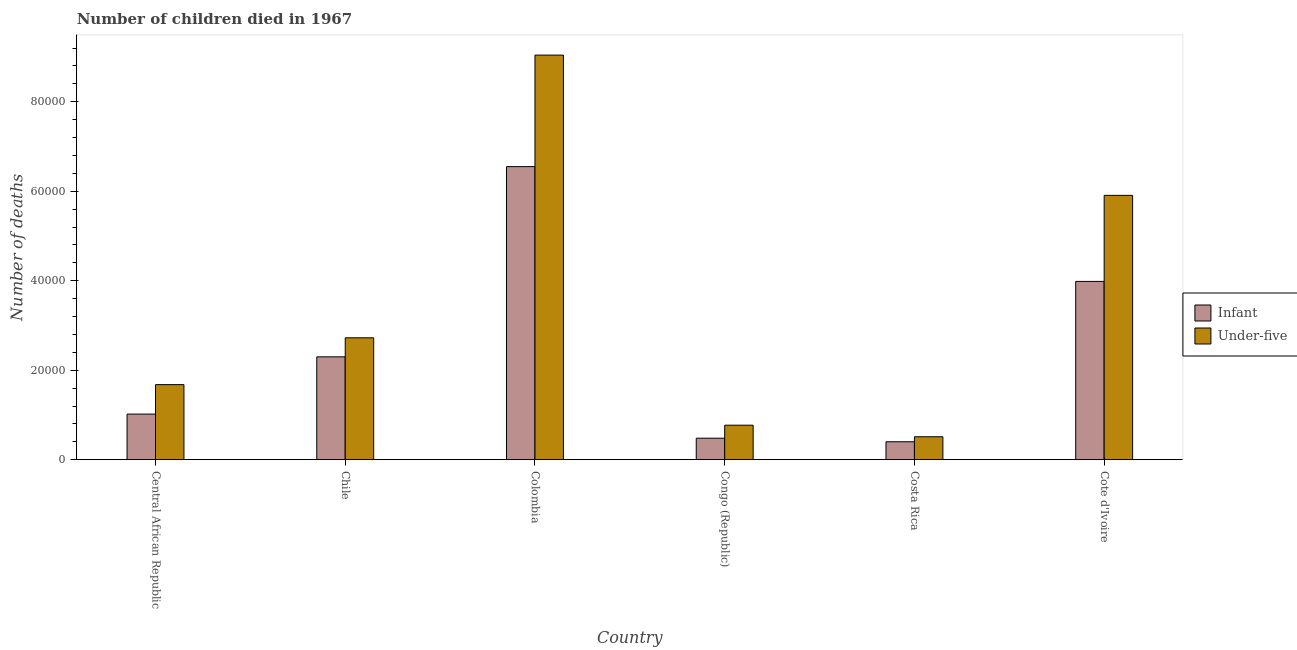How many different coloured bars are there?
Ensure brevity in your answer.  2. Are the number of bars per tick equal to the number of legend labels?
Offer a terse response. Yes. Are the number of bars on each tick of the X-axis equal?
Offer a very short reply. Yes. How many bars are there on the 2nd tick from the left?
Keep it short and to the point. 2. How many bars are there on the 4th tick from the right?
Keep it short and to the point. 2. What is the label of the 6th group of bars from the left?
Ensure brevity in your answer.  Cote d'Ivoire. In how many cases, is the number of bars for a given country not equal to the number of legend labels?
Your answer should be very brief. 0. What is the number of under-five deaths in Congo (Republic)?
Make the answer very short. 7710. Across all countries, what is the maximum number of under-five deaths?
Make the answer very short. 9.04e+04. Across all countries, what is the minimum number of infant deaths?
Make the answer very short. 4011. In which country was the number of under-five deaths maximum?
Keep it short and to the point. Colombia. What is the total number of infant deaths in the graph?
Your answer should be very brief. 1.47e+05. What is the difference between the number of infant deaths in Chile and that in Cote d'Ivoire?
Your answer should be compact. -1.69e+04. What is the difference between the number of under-five deaths in Chile and the number of infant deaths in Cote d'Ivoire?
Provide a short and direct response. -1.26e+04. What is the average number of under-five deaths per country?
Offer a very short reply. 3.44e+04. What is the difference between the number of under-five deaths and number of infant deaths in Chile?
Ensure brevity in your answer.  4252. In how many countries, is the number of under-five deaths greater than 28000 ?
Ensure brevity in your answer.  2. What is the ratio of the number of under-five deaths in Costa Rica to that in Cote d'Ivoire?
Provide a short and direct response. 0.09. What is the difference between the highest and the second highest number of infant deaths?
Your answer should be very brief. 2.57e+04. What is the difference between the highest and the lowest number of infant deaths?
Make the answer very short. 6.15e+04. In how many countries, is the number of under-five deaths greater than the average number of under-five deaths taken over all countries?
Your answer should be very brief. 2. What does the 1st bar from the left in Congo (Republic) represents?
Provide a succinct answer. Infant. What does the 2nd bar from the right in Colombia represents?
Make the answer very short. Infant. How many countries are there in the graph?
Provide a short and direct response. 6. Does the graph contain any zero values?
Make the answer very short. No. How many legend labels are there?
Your response must be concise. 2. What is the title of the graph?
Offer a terse response. Number of children died in 1967. Does "Primary completion rate" appear as one of the legend labels in the graph?
Your response must be concise. No. What is the label or title of the X-axis?
Keep it short and to the point. Country. What is the label or title of the Y-axis?
Offer a terse response. Number of deaths. What is the Number of deaths of Infant in Central African Republic?
Offer a terse response. 1.02e+04. What is the Number of deaths in Under-five in Central African Republic?
Offer a terse response. 1.68e+04. What is the Number of deaths in Infant in Chile?
Give a very brief answer. 2.30e+04. What is the Number of deaths of Under-five in Chile?
Ensure brevity in your answer.  2.72e+04. What is the Number of deaths of Infant in Colombia?
Your answer should be compact. 6.55e+04. What is the Number of deaths in Under-five in Colombia?
Make the answer very short. 9.04e+04. What is the Number of deaths in Infant in Congo (Republic)?
Make the answer very short. 4806. What is the Number of deaths of Under-five in Congo (Republic)?
Offer a very short reply. 7710. What is the Number of deaths of Infant in Costa Rica?
Your answer should be very brief. 4011. What is the Number of deaths of Under-five in Costa Rica?
Provide a succinct answer. 5127. What is the Number of deaths of Infant in Cote d'Ivoire?
Your answer should be very brief. 3.98e+04. What is the Number of deaths of Under-five in Cote d'Ivoire?
Offer a very short reply. 5.91e+04. Across all countries, what is the maximum Number of deaths of Infant?
Provide a short and direct response. 6.55e+04. Across all countries, what is the maximum Number of deaths of Under-five?
Provide a succinct answer. 9.04e+04. Across all countries, what is the minimum Number of deaths in Infant?
Give a very brief answer. 4011. Across all countries, what is the minimum Number of deaths of Under-five?
Your response must be concise. 5127. What is the total Number of deaths of Infant in the graph?
Provide a short and direct response. 1.47e+05. What is the total Number of deaths in Under-five in the graph?
Ensure brevity in your answer.  2.06e+05. What is the difference between the Number of deaths in Infant in Central African Republic and that in Chile?
Provide a succinct answer. -1.28e+04. What is the difference between the Number of deaths in Under-five in Central African Republic and that in Chile?
Make the answer very short. -1.05e+04. What is the difference between the Number of deaths of Infant in Central African Republic and that in Colombia?
Your answer should be very brief. -5.53e+04. What is the difference between the Number of deaths in Under-five in Central African Republic and that in Colombia?
Keep it short and to the point. -7.36e+04. What is the difference between the Number of deaths in Infant in Central African Republic and that in Congo (Republic)?
Give a very brief answer. 5389. What is the difference between the Number of deaths of Under-five in Central African Republic and that in Congo (Republic)?
Make the answer very short. 9065. What is the difference between the Number of deaths of Infant in Central African Republic and that in Costa Rica?
Offer a terse response. 6184. What is the difference between the Number of deaths of Under-five in Central African Republic and that in Costa Rica?
Keep it short and to the point. 1.16e+04. What is the difference between the Number of deaths in Infant in Central African Republic and that in Cote d'Ivoire?
Offer a very short reply. -2.96e+04. What is the difference between the Number of deaths in Under-five in Central African Republic and that in Cote d'Ivoire?
Your response must be concise. -4.23e+04. What is the difference between the Number of deaths of Infant in Chile and that in Colombia?
Make the answer very short. -4.25e+04. What is the difference between the Number of deaths in Under-five in Chile and that in Colombia?
Your answer should be compact. -6.32e+04. What is the difference between the Number of deaths in Infant in Chile and that in Congo (Republic)?
Your answer should be compact. 1.82e+04. What is the difference between the Number of deaths of Under-five in Chile and that in Congo (Republic)?
Your answer should be very brief. 1.95e+04. What is the difference between the Number of deaths of Infant in Chile and that in Costa Rica?
Your answer should be very brief. 1.90e+04. What is the difference between the Number of deaths in Under-five in Chile and that in Costa Rica?
Offer a terse response. 2.21e+04. What is the difference between the Number of deaths in Infant in Chile and that in Cote d'Ivoire?
Provide a short and direct response. -1.69e+04. What is the difference between the Number of deaths in Under-five in Chile and that in Cote d'Ivoire?
Your answer should be compact. -3.18e+04. What is the difference between the Number of deaths of Infant in Colombia and that in Congo (Republic)?
Your response must be concise. 6.07e+04. What is the difference between the Number of deaths in Under-five in Colombia and that in Congo (Republic)?
Offer a very short reply. 8.27e+04. What is the difference between the Number of deaths of Infant in Colombia and that in Costa Rica?
Provide a short and direct response. 6.15e+04. What is the difference between the Number of deaths of Under-five in Colombia and that in Costa Rica?
Provide a short and direct response. 8.53e+04. What is the difference between the Number of deaths in Infant in Colombia and that in Cote d'Ivoire?
Provide a succinct answer. 2.57e+04. What is the difference between the Number of deaths of Under-five in Colombia and that in Cote d'Ivoire?
Keep it short and to the point. 3.13e+04. What is the difference between the Number of deaths in Infant in Congo (Republic) and that in Costa Rica?
Give a very brief answer. 795. What is the difference between the Number of deaths in Under-five in Congo (Republic) and that in Costa Rica?
Offer a very short reply. 2583. What is the difference between the Number of deaths of Infant in Congo (Republic) and that in Cote d'Ivoire?
Your response must be concise. -3.50e+04. What is the difference between the Number of deaths in Under-five in Congo (Republic) and that in Cote d'Ivoire?
Provide a short and direct response. -5.14e+04. What is the difference between the Number of deaths of Infant in Costa Rica and that in Cote d'Ivoire?
Ensure brevity in your answer.  -3.58e+04. What is the difference between the Number of deaths of Under-five in Costa Rica and that in Cote d'Ivoire?
Give a very brief answer. -5.39e+04. What is the difference between the Number of deaths of Infant in Central African Republic and the Number of deaths of Under-five in Chile?
Give a very brief answer. -1.70e+04. What is the difference between the Number of deaths of Infant in Central African Republic and the Number of deaths of Under-five in Colombia?
Ensure brevity in your answer.  -8.02e+04. What is the difference between the Number of deaths in Infant in Central African Republic and the Number of deaths in Under-five in Congo (Republic)?
Your response must be concise. 2485. What is the difference between the Number of deaths of Infant in Central African Republic and the Number of deaths of Under-five in Costa Rica?
Provide a succinct answer. 5068. What is the difference between the Number of deaths of Infant in Central African Republic and the Number of deaths of Under-five in Cote d'Ivoire?
Provide a succinct answer. -4.89e+04. What is the difference between the Number of deaths in Infant in Chile and the Number of deaths in Under-five in Colombia?
Offer a terse response. -6.74e+04. What is the difference between the Number of deaths in Infant in Chile and the Number of deaths in Under-five in Congo (Republic)?
Offer a very short reply. 1.53e+04. What is the difference between the Number of deaths in Infant in Chile and the Number of deaths in Under-five in Costa Rica?
Make the answer very short. 1.79e+04. What is the difference between the Number of deaths in Infant in Chile and the Number of deaths in Under-five in Cote d'Ivoire?
Your response must be concise. -3.61e+04. What is the difference between the Number of deaths of Infant in Colombia and the Number of deaths of Under-five in Congo (Republic)?
Provide a succinct answer. 5.78e+04. What is the difference between the Number of deaths in Infant in Colombia and the Number of deaths in Under-five in Costa Rica?
Offer a terse response. 6.04e+04. What is the difference between the Number of deaths of Infant in Colombia and the Number of deaths of Under-five in Cote d'Ivoire?
Your answer should be compact. 6424. What is the difference between the Number of deaths of Infant in Congo (Republic) and the Number of deaths of Under-five in Costa Rica?
Ensure brevity in your answer.  -321. What is the difference between the Number of deaths in Infant in Congo (Republic) and the Number of deaths in Under-five in Cote d'Ivoire?
Offer a very short reply. -5.43e+04. What is the difference between the Number of deaths of Infant in Costa Rica and the Number of deaths of Under-five in Cote d'Ivoire?
Your answer should be compact. -5.51e+04. What is the average Number of deaths of Infant per country?
Give a very brief answer. 2.46e+04. What is the average Number of deaths of Under-five per country?
Offer a very short reply. 3.44e+04. What is the difference between the Number of deaths of Infant and Number of deaths of Under-five in Central African Republic?
Make the answer very short. -6580. What is the difference between the Number of deaths of Infant and Number of deaths of Under-five in Chile?
Keep it short and to the point. -4252. What is the difference between the Number of deaths of Infant and Number of deaths of Under-five in Colombia?
Give a very brief answer. -2.49e+04. What is the difference between the Number of deaths in Infant and Number of deaths in Under-five in Congo (Republic)?
Your response must be concise. -2904. What is the difference between the Number of deaths of Infant and Number of deaths of Under-five in Costa Rica?
Give a very brief answer. -1116. What is the difference between the Number of deaths of Infant and Number of deaths of Under-five in Cote d'Ivoire?
Your answer should be very brief. -1.92e+04. What is the ratio of the Number of deaths in Infant in Central African Republic to that in Chile?
Your answer should be compact. 0.44. What is the ratio of the Number of deaths in Under-five in Central African Republic to that in Chile?
Your answer should be compact. 0.62. What is the ratio of the Number of deaths of Infant in Central African Republic to that in Colombia?
Your response must be concise. 0.16. What is the ratio of the Number of deaths in Under-five in Central African Republic to that in Colombia?
Keep it short and to the point. 0.19. What is the ratio of the Number of deaths in Infant in Central African Republic to that in Congo (Republic)?
Provide a succinct answer. 2.12. What is the ratio of the Number of deaths of Under-five in Central African Republic to that in Congo (Republic)?
Ensure brevity in your answer.  2.18. What is the ratio of the Number of deaths of Infant in Central African Republic to that in Costa Rica?
Keep it short and to the point. 2.54. What is the ratio of the Number of deaths in Under-five in Central African Republic to that in Costa Rica?
Your answer should be very brief. 3.27. What is the ratio of the Number of deaths in Infant in Central African Republic to that in Cote d'Ivoire?
Offer a terse response. 0.26. What is the ratio of the Number of deaths in Under-five in Central African Republic to that in Cote d'Ivoire?
Make the answer very short. 0.28. What is the ratio of the Number of deaths of Infant in Chile to that in Colombia?
Your answer should be compact. 0.35. What is the ratio of the Number of deaths of Under-five in Chile to that in Colombia?
Ensure brevity in your answer.  0.3. What is the ratio of the Number of deaths of Infant in Chile to that in Congo (Republic)?
Offer a very short reply. 4.78. What is the ratio of the Number of deaths in Under-five in Chile to that in Congo (Republic)?
Your answer should be very brief. 3.53. What is the ratio of the Number of deaths of Infant in Chile to that in Costa Rica?
Your answer should be compact. 5.73. What is the ratio of the Number of deaths in Under-five in Chile to that in Costa Rica?
Provide a succinct answer. 5.31. What is the ratio of the Number of deaths of Infant in Chile to that in Cote d'Ivoire?
Your answer should be very brief. 0.58. What is the ratio of the Number of deaths in Under-five in Chile to that in Cote d'Ivoire?
Your answer should be compact. 0.46. What is the ratio of the Number of deaths in Infant in Colombia to that in Congo (Republic)?
Your answer should be very brief. 13.63. What is the ratio of the Number of deaths in Under-five in Colombia to that in Congo (Republic)?
Offer a very short reply. 11.73. What is the ratio of the Number of deaths of Infant in Colombia to that in Costa Rica?
Your answer should be compact. 16.33. What is the ratio of the Number of deaths in Under-five in Colombia to that in Costa Rica?
Ensure brevity in your answer.  17.64. What is the ratio of the Number of deaths of Infant in Colombia to that in Cote d'Ivoire?
Provide a succinct answer. 1.64. What is the ratio of the Number of deaths in Under-five in Colombia to that in Cote d'Ivoire?
Offer a terse response. 1.53. What is the ratio of the Number of deaths of Infant in Congo (Republic) to that in Costa Rica?
Your answer should be compact. 1.2. What is the ratio of the Number of deaths of Under-five in Congo (Republic) to that in Costa Rica?
Provide a succinct answer. 1.5. What is the ratio of the Number of deaths in Infant in Congo (Republic) to that in Cote d'Ivoire?
Make the answer very short. 0.12. What is the ratio of the Number of deaths of Under-five in Congo (Republic) to that in Cote d'Ivoire?
Your response must be concise. 0.13. What is the ratio of the Number of deaths in Infant in Costa Rica to that in Cote d'Ivoire?
Your answer should be compact. 0.1. What is the ratio of the Number of deaths in Under-five in Costa Rica to that in Cote d'Ivoire?
Keep it short and to the point. 0.09. What is the difference between the highest and the second highest Number of deaths of Infant?
Provide a short and direct response. 2.57e+04. What is the difference between the highest and the second highest Number of deaths in Under-five?
Offer a very short reply. 3.13e+04. What is the difference between the highest and the lowest Number of deaths of Infant?
Your response must be concise. 6.15e+04. What is the difference between the highest and the lowest Number of deaths in Under-five?
Provide a succinct answer. 8.53e+04. 